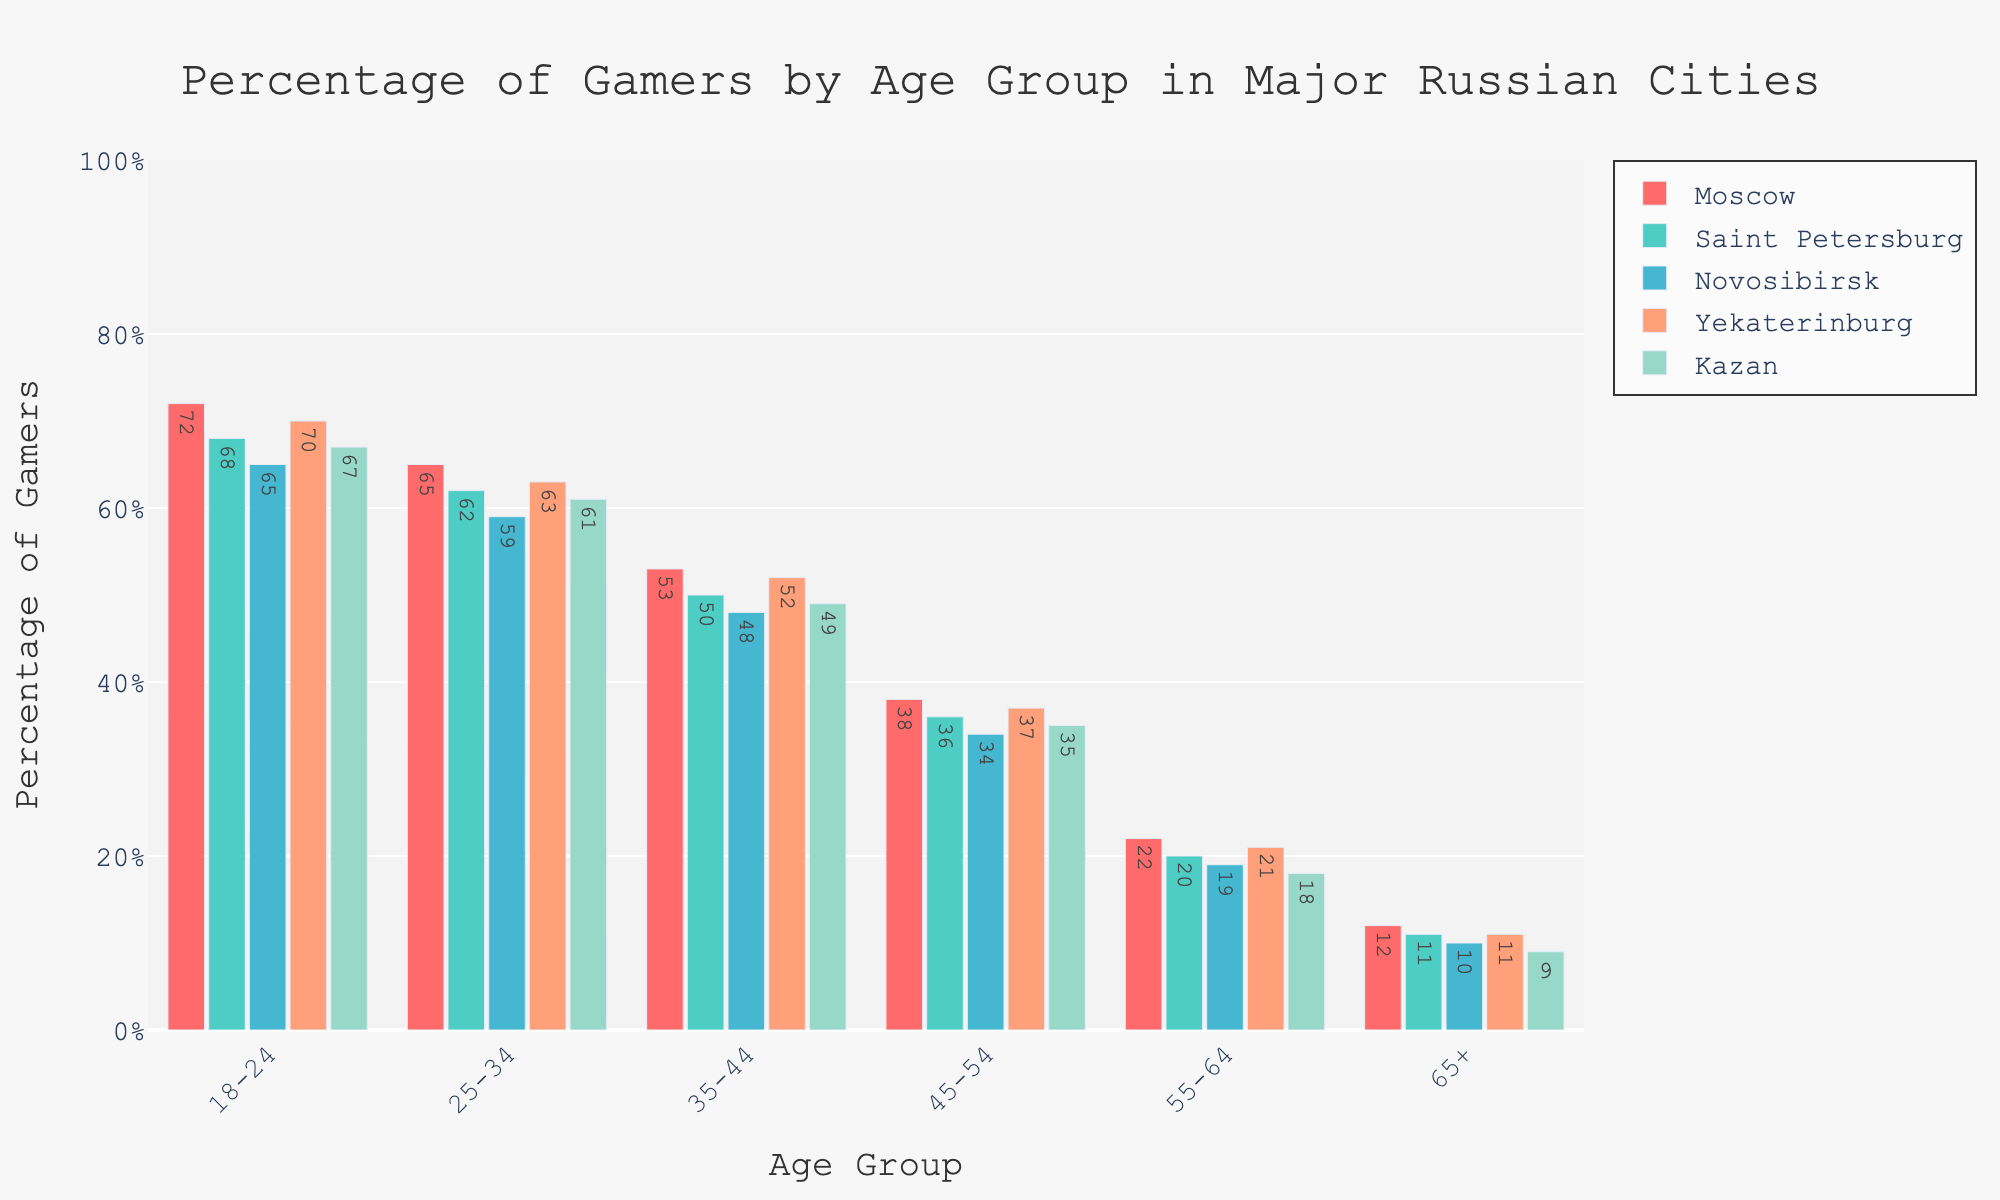Which age group in Moscow has the highest percentage of gamers? Look at the values for each age group in the Moscow column. The highest value is 72% for the 18-24 age group.
Answer: 18-24 How does the percentage of gamers in the 25-34 age group in Yekaterinburg compare to that in Saint Petersburg? The percentage of gamers in the 25-34 age group is 63% in Yekaterinburg and 62% in Saint Petersburg. Yekaterinburg has a 1% higher percentage.
Answer: Yekaterinburg has 1% more What's the difference between the percentage of gamers in the 45-54 and 55-64 age groups in Kazan? The percentage for the 45-54 age group in Kazan is 35%, while for the 55-64 age group, it is 18%. The difference is 35% - 18% = 17%.
Answer: 17% Among the 35-44 age group, which city has the least percentage of gamers? Look at the values for the 35-44 age group in all cities. Novosibirsk has the lowest percentage with 48%.
Answer: Novosibirsk What's the average percentage of gamers aged 65+ across all cities? Add the percentages of gamers aged 65+ for all cities and divide by the number of cities: (12 + 11 + 10 + 11 + 9) / 5 = 10.6%.
Answer: 10.6% Which city has the highest percentage of gamers in the 18-24 age group? Compare the percentages for the 18-24 age group across all cities. Moscow has the highest with 72%.
Answer: Moscow What is the total percentage of gamers in all age groups in Novosibirsk? Sum the percentages for all age groups in Novosibirsk: 65 + 59 + 48 + 34 + 19 + 10 = 235%.
Answer: 235% For the 35-44 age group, which city has exactly half the percentage of gamers as Moscow? Moscow has 53% gamers in the 35-44 age group. Look for a city with roughly 26.5%. None of the cities have exactly half, but the closest is Kazan with 49%.
Answer: None Which city has more gamers aged 45-54: Saint Petersburg or Kazan? Compare the percentages for the 45-54 age group: Saint Petersburg has 36%, Kazan has 35%. Saint Petersburg has 1% more.
Answer: Saint Petersburg 